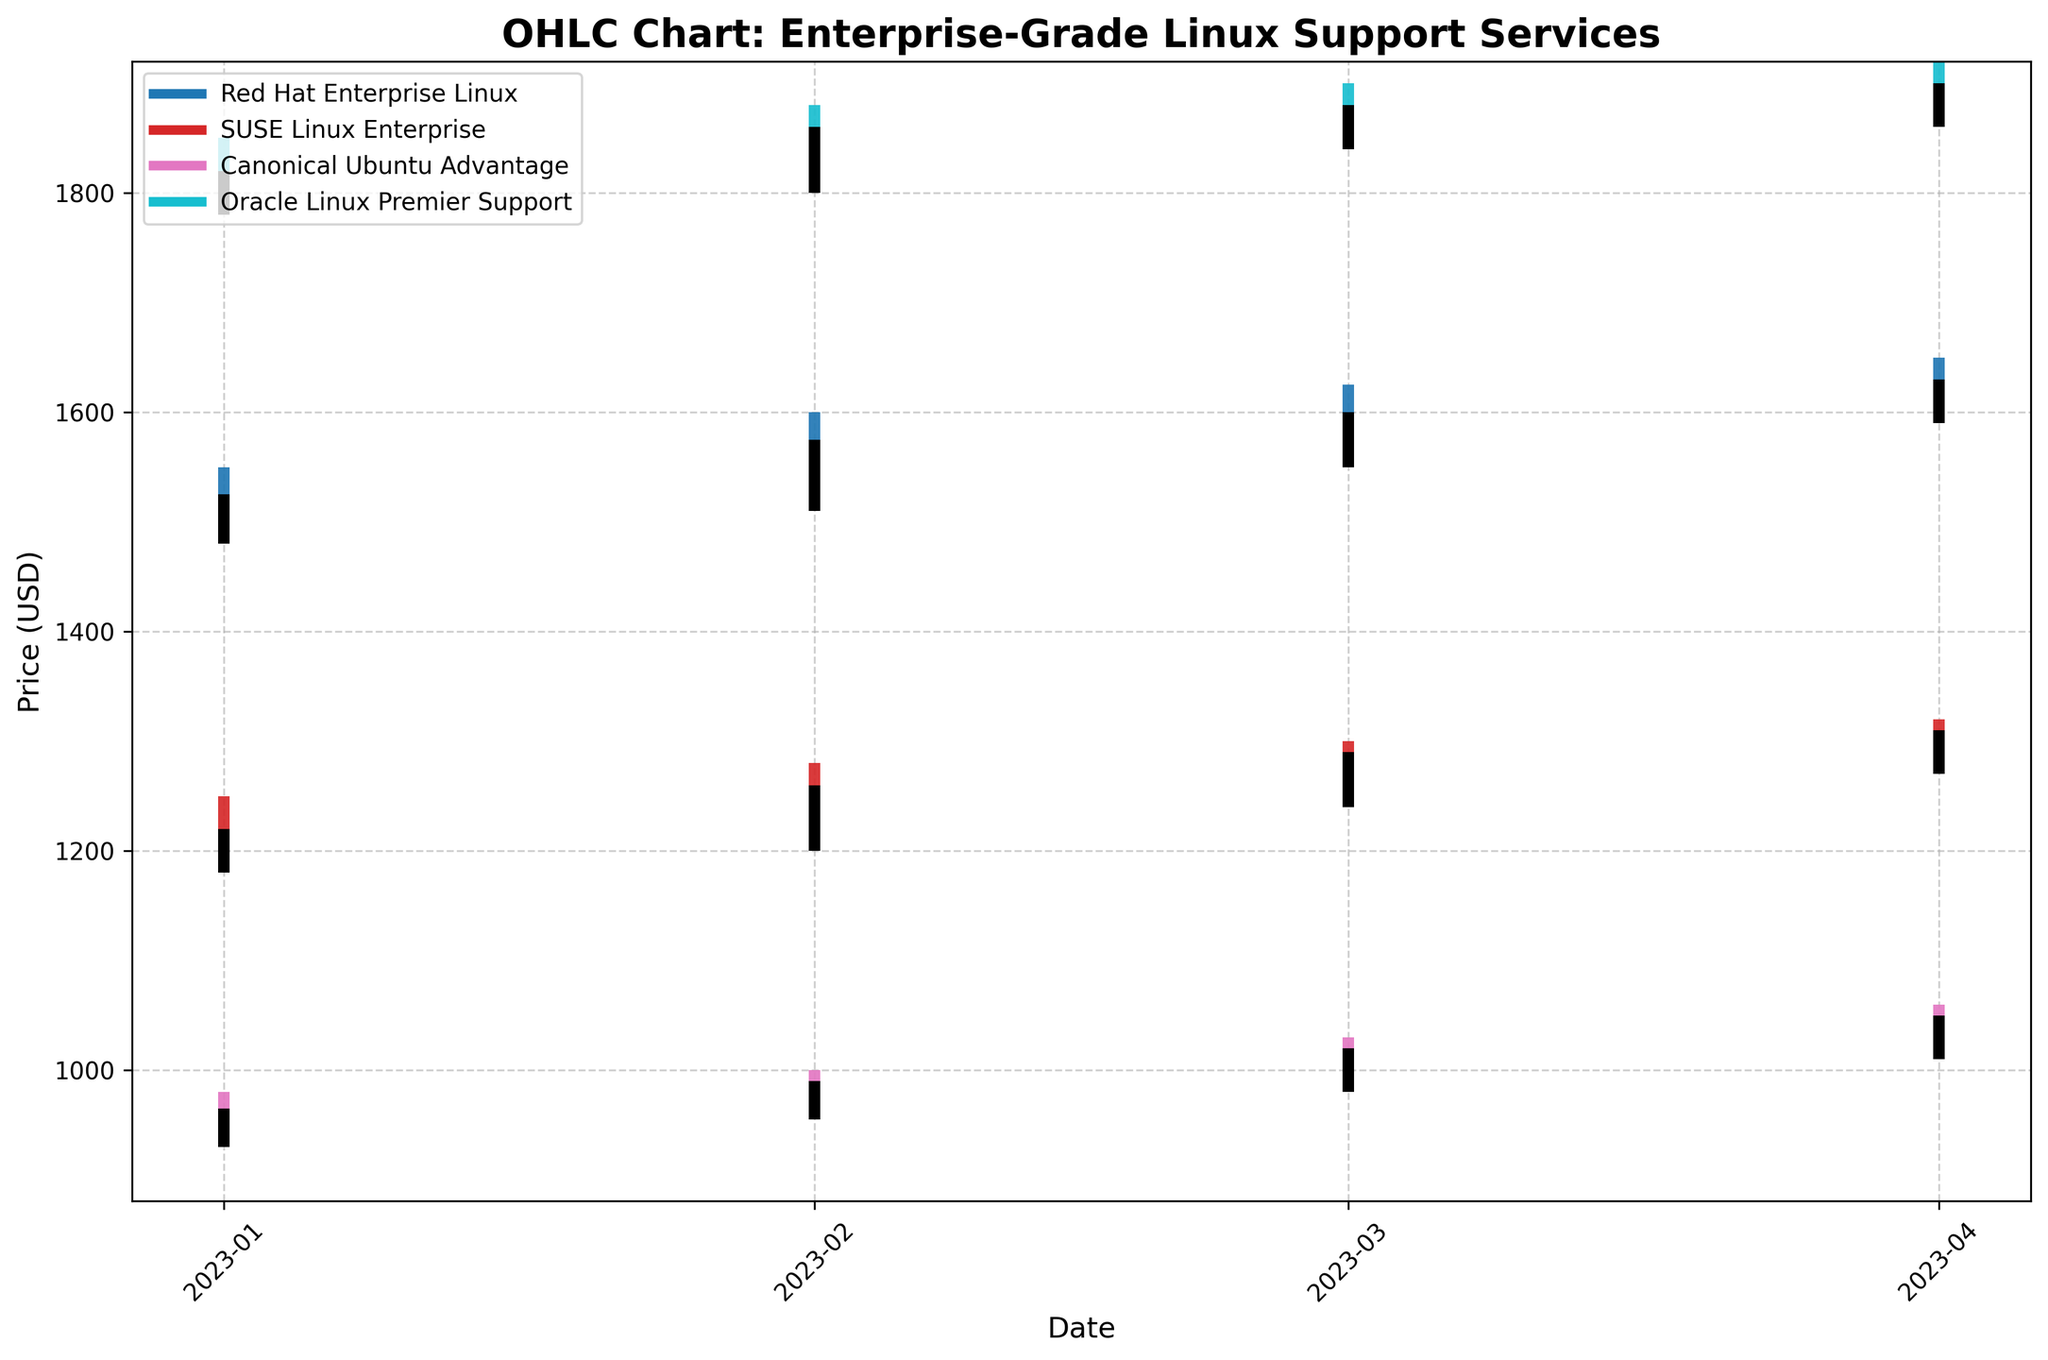What is the title of the figure? The title of the figure is usually displayed at the top, in larger and bold font. In this case, the title "OHLC Chart: Enterprise-Grade Linux Support Services" is clearly visible.
Answer: OHLC Chart: Enterprise-Grade Linux Support Services Which vendor has the highest closing price in April 2023? To find the highest closing price in April 2023, scan through the closing prices for each vendor in that month. The closing prices are: Red Hat ($1630), SUSE ($1310), Canonical ($1050), Oracle ($1900). Oracle Linux Premier Support has the highest closing price.
Answer: Oracle Linux Premier Support How many vendors are represented in the chart? Count the different colors and corresponding legend entries. Each unique color corresponds to a different vendor, resulting in a total of four unique vendors.
Answer: 4 Which vendor showed the largest increase in their closing price from January to April 2023? Calculate the change in closing prices for each vendor between January and April: 
Red Hat: 1525 to 1630 (105 increase)
SUSE: 1220 to 1310 (90 increase)
Canonical: 965 to 1050 (85 increase)
Oracle: 1820 to 1900 (80 increase)
Red Hat Enterprise Linux has the largest increase in closing price.
Answer: Red Hat Enterprise Linux What is the average closing price of Canonical Ubuntu Advantage across the four months? Add the closing prices of Canonical Ubuntu Advantage from January to April, then divide by 4: \( (965 + 990 + 1020 + 1050) / 4 \) The sum is 4025 and dividing by 4 gives 1006.25.
Answer: 1006.25 Between SUSE Linux Enterprise and Red Hat Enterprise Linux, which vendor had a more significant peak-to-trough spread in April 2023? Calculate the high-to-low spread for each vendor in April:
Red Hat: 1650 - 1590 = 60
SUSE: 1320 - 1270 = 50
Red Hat Enterprise Linux has a more significant peak-to-trough spread.
Answer: Red Hat Enterprise Linux Which month had the least price fluctuation for Canonical Ubuntu Advantage? The months' high-low spreads for Canonical Ubuntu Advantage are:
January: 980 - 930 = 50
February: 1000 - 955 = 45
March: 1030 - 980 = 50
April: 1060 - 1010 = 50
February has the least fluctuation with a spread of 45.
Answer: February Which vendor saw their opening prices consistently increase from January to April 2023? Check the opening prices for each vendor across the months:
Red Hat: 1499, 1525, 1575, 1600 (increasing)
SUSE: 1200, 1220, 1260, 1290 (increasing)
Canonical: 950, 965, 990, 1020 (increasing)
Oracle: 1800, 1820, 1860, 1880 (increasing)
All vendors had their opening prices consistently increase.
Answer: All vendors How has the volatility in the price of Oracle Linux Premier Support changed over the months from January to April 2023? Analyze the difference between the high and low prices for each month:
January: 1850 - 1780 = 70
February: 1880 - 1800 = 80
March: 1900 - 1840 = 60
April: 1920 - 1860 = 60
The volatility peaked in February and reduced in March and April.
Answer: Decreased after peaking in February 